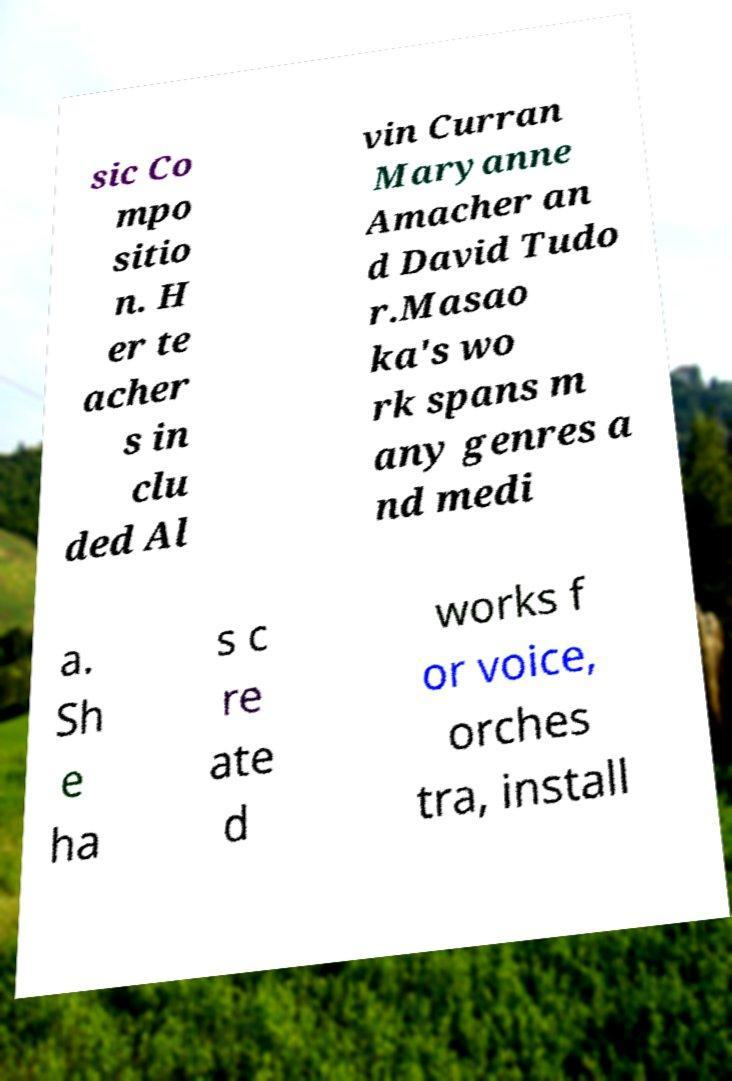Can you accurately transcribe the text from the provided image for me? sic Co mpo sitio n. H er te acher s in clu ded Al vin Curran Maryanne Amacher an d David Tudo r.Masao ka's wo rk spans m any genres a nd medi a. Sh e ha s c re ate d works f or voice, orches tra, install 